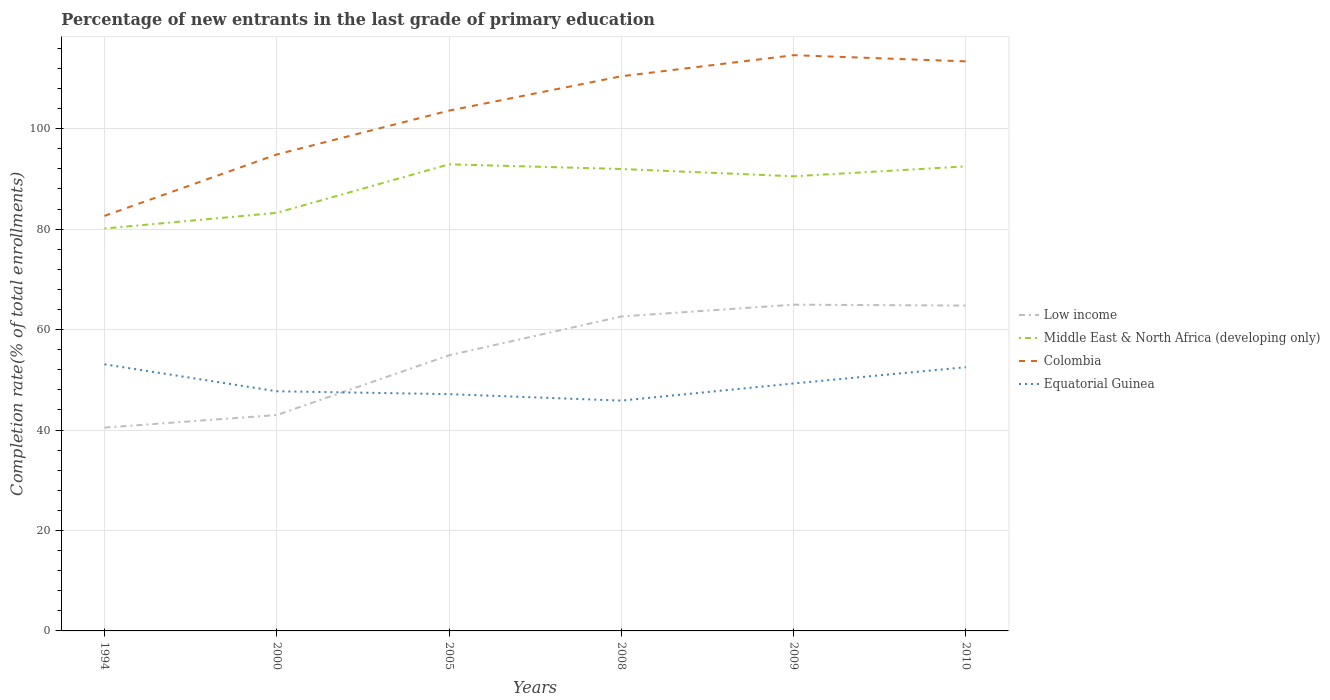Does the line corresponding to Middle East & North Africa (developing only) intersect with the line corresponding to Equatorial Guinea?
Your answer should be compact. No. Across all years, what is the maximum percentage of new entrants in Middle East & North Africa (developing only)?
Make the answer very short. 80.12. In which year was the percentage of new entrants in Equatorial Guinea maximum?
Your answer should be compact. 2008. What is the total percentage of new entrants in Equatorial Guinea in the graph?
Make the answer very short. 5.94. What is the difference between the highest and the second highest percentage of new entrants in Colombia?
Give a very brief answer. 32. What is the difference between the highest and the lowest percentage of new entrants in Equatorial Guinea?
Provide a succinct answer. 3. Is the percentage of new entrants in Middle East & North Africa (developing only) strictly greater than the percentage of new entrants in Equatorial Guinea over the years?
Provide a short and direct response. No. How many years are there in the graph?
Your answer should be compact. 6. What is the difference between two consecutive major ticks on the Y-axis?
Your response must be concise. 20. Where does the legend appear in the graph?
Your response must be concise. Center right. How many legend labels are there?
Give a very brief answer. 4. How are the legend labels stacked?
Your answer should be compact. Vertical. What is the title of the graph?
Offer a very short reply. Percentage of new entrants in the last grade of primary education. What is the label or title of the Y-axis?
Make the answer very short. Completion rate(% of total enrollments). What is the Completion rate(% of total enrollments) of Low income in 1994?
Make the answer very short. 40.48. What is the Completion rate(% of total enrollments) in Middle East & North Africa (developing only) in 1994?
Offer a terse response. 80.12. What is the Completion rate(% of total enrollments) in Colombia in 1994?
Offer a very short reply. 82.63. What is the Completion rate(% of total enrollments) in Equatorial Guinea in 1994?
Make the answer very short. 53.08. What is the Completion rate(% of total enrollments) in Low income in 2000?
Provide a succinct answer. 42.98. What is the Completion rate(% of total enrollments) in Middle East & North Africa (developing only) in 2000?
Provide a short and direct response. 83.23. What is the Completion rate(% of total enrollments) in Colombia in 2000?
Provide a succinct answer. 94.86. What is the Completion rate(% of total enrollments) of Equatorial Guinea in 2000?
Keep it short and to the point. 47.72. What is the Completion rate(% of total enrollments) of Low income in 2005?
Keep it short and to the point. 54.87. What is the Completion rate(% of total enrollments) of Middle East & North Africa (developing only) in 2005?
Provide a short and direct response. 92.9. What is the Completion rate(% of total enrollments) in Colombia in 2005?
Provide a short and direct response. 103.59. What is the Completion rate(% of total enrollments) of Equatorial Guinea in 2005?
Your answer should be very brief. 47.14. What is the Completion rate(% of total enrollments) in Low income in 2008?
Your answer should be very brief. 62.61. What is the Completion rate(% of total enrollments) of Middle East & North Africa (developing only) in 2008?
Give a very brief answer. 91.97. What is the Completion rate(% of total enrollments) in Colombia in 2008?
Your response must be concise. 110.43. What is the Completion rate(% of total enrollments) of Equatorial Guinea in 2008?
Offer a terse response. 45.85. What is the Completion rate(% of total enrollments) of Low income in 2009?
Make the answer very short. 64.95. What is the Completion rate(% of total enrollments) in Middle East & North Africa (developing only) in 2009?
Provide a short and direct response. 90.51. What is the Completion rate(% of total enrollments) in Colombia in 2009?
Offer a terse response. 114.62. What is the Completion rate(% of total enrollments) of Equatorial Guinea in 2009?
Keep it short and to the point. 49.27. What is the Completion rate(% of total enrollments) in Low income in 2010?
Make the answer very short. 64.77. What is the Completion rate(% of total enrollments) in Middle East & North Africa (developing only) in 2010?
Offer a terse response. 92.48. What is the Completion rate(% of total enrollments) in Colombia in 2010?
Offer a very short reply. 113.39. What is the Completion rate(% of total enrollments) of Equatorial Guinea in 2010?
Ensure brevity in your answer.  52.5. Across all years, what is the maximum Completion rate(% of total enrollments) in Low income?
Ensure brevity in your answer.  64.95. Across all years, what is the maximum Completion rate(% of total enrollments) in Middle East & North Africa (developing only)?
Offer a terse response. 92.9. Across all years, what is the maximum Completion rate(% of total enrollments) of Colombia?
Ensure brevity in your answer.  114.62. Across all years, what is the maximum Completion rate(% of total enrollments) of Equatorial Guinea?
Provide a succinct answer. 53.08. Across all years, what is the minimum Completion rate(% of total enrollments) of Low income?
Provide a short and direct response. 40.48. Across all years, what is the minimum Completion rate(% of total enrollments) in Middle East & North Africa (developing only)?
Your answer should be compact. 80.12. Across all years, what is the minimum Completion rate(% of total enrollments) of Colombia?
Offer a terse response. 82.63. Across all years, what is the minimum Completion rate(% of total enrollments) in Equatorial Guinea?
Your answer should be very brief. 45.85. What is the total Completion rate(% of total enrollments) in Low income in the graph?
Provide a short and direct response. 330.67. What is the total Completion rate(% of total enrollments) of Middle East & North Africa (developing only) in the graph?
Ensure brevity in your answer.  531.21. What is the total Completion rate(% of total enrollments) in Colombia in the graph?
Ensure brevity in your answer.  619.52. What is the total Completion rate(% of total enrollments) of Equatorial Guinea in the graph?
Provide a succinct answer. 295.56. What is the difference between the Completion rate(% of total enrollments) of Low income in 1994 and that in 2000?
Ensure brevity in your answer.  -2.5. What is the difference between the Completion rate(% of total enrollments) of Middle East & North Africa (developing only) in 1994 and that in 2000?
Make the answer very short. -3.12. What is the difference between the Completion rate(% of total enrollments) in Colombia in 1994 and that in 2000?
Your answer should be very brief. -12.23. What is the difference between the Completion rate(% of total enrollments) in Equatorial Guinea in 1994 and that in 2000?
Offer a terse response. 5.36. What is the difference between the Completion rate(% of total enrollments) of Low income in 1994 and that in 2005?
Your response must be concise. -14.39. What is the difference between the Completion rate(% of total enrollments) of Middle East & North Africa (developing only) in 1994 and that in 2005?
Provide a short and direct response. -12.78. What is the difference between the Completion rate(% of total enrollments) of Colombia in 1994 and that in 2005?
Offer a terse response. -20.96. What is the difference between the Completion rate(% of total enrollments) of Equatorial Guinea in 1994 and that in 2005?
Ensure brevity in your answer.  5.94. What is the difference between the Completion rate(% of total enrollments) of Low income in 1994 and that in 2008?
Provide a short and direct response. -22.12. What is the difference between the Completion rate(% of total enrollments) in Middle East & North Africa (developing only) in 1994 and that in 2008?
Give a very brief answer. -11.85. What is the difference between the Completion rate(% of total enrollments) of Colombia in 1994 and that in 2008?
Your response must be concise. -27.8. What is the difference between the Completion rate(% of total enrollments) in Equatorial Guinea in 1994 and that in 2008?
Keep it short and to the point. 7.23. What is the difference between the Completion rate(% of total enrollments) of Low income in 1994 and that in 2009?
Your answer should be compact. -24.47. What is the difference between the Completion rate(% of total enrollments) in Middle East & North Africa (developing only) in 1994 and that in 2009?
Offer a very short reply. -10.4. What is the difference between the Completion rate(% of total enrollments) of Colombia in 1994 and that in 2009?
Offer a terse response. -32. What is the difference between the Completion rate(% of total enrollments) of Equatorial Guinea in 1994 and that in 2009?
Ensure brevity in your answer.  3.81. What is the difference between the Completion rate(% of total enrollments) of Low income in 1994 and that in 2010?
Make the answer very short. -24.29. What is the difference between the Completion rate(% of total enrollments) in Middle East & North Africa (developing only) in 1994 and that in 2010?
Your answer should be very brief. -12.37. What is the difference between the Completion rate(% of total enrollments) in Colombia in 1994 and that in 2010?
Ensure brevity in your answer.  -30.77. What is the difference between the Completion rate(% of total enrollments) in Equatorial Guinea in 1994 and that in 2010?
Your answer should be very brief. 0.57. What is the difference between the Completion rate(% of total enrollments) of Low income in 2000 and that in 2005?
Offer a very short reply. -11.89. What is the difference between the Completion rate(% of total enrollments) in Middle East & North Africa (developing only) in 2000 and that in 2005?
Give a very brief answer. -9.66. What is the difference between the Completion rate(% of total enrollments) of Colombia in 2000 and that in 2005?
Your answer should be compact. -8.73. What is the difference between the Completion rate(% of total enrollments) in Equatorial Guinea in 2000 and that in 2005?
Your answer should be compact. 0.58. What is the difference between the Completion rate(% of total enrollments) in Low income in 2000 and that in 2008?
Your response must be concise. -19.62. What is the difference between the Completion rate(% of total enrollments) of Middle East & North Africa (developing only) in 2000 and that in 2008?
Your answer should be compact. -8.73. What is the difference between the Completion rate(% of total enrollments) in Colombia in 2000 and that in 2008?
Offer a terse response. -15.57. What is the difference between the Completion rate(% of total enrollments) of Equatorial Guinea in 2000 and that in 2008?
Your answer should be very brief. 1.86. What is the difference between the Completion rate(% of total enrollments) in Low income in 2000 and that in 2009?
Provide a short and direct response. -21.97. What is the difference between the Completion rate(% of total enrollments) in Middle East & North Africa (developing only) in 2000 and that in 2009?
Ensure brevity in your answer.  -7.28. What is the difference between the Completion rate(% of total enrollments) of Colombia in 2000 and that in 2009?
Make the answer very short. -19.77. What is the difference between the Completion rate(% of total enrollments) of Equatorial Guinea in 2000 and that in 2009?
Your response must be concise. -1.56. What is the difference between the Completion rate(% of total enrollments) in Low income in 2000 and that in 2010?
Your answer should be compact. -21.79. What is the difference between the Completion rate(% of total enrollments) in Middle East & North Africa (developing only) in 2000 and that in 2010?
Provide a succinct answer. -9.25. What is the difference between the Completion rate(% of total enrollments) of Colombia in 2000 and that in 2010?
Offer a very short reply. -18.54. What is the difference between the Completion rate(% of total enrollments) in Equatorial Guinea in 2000 and that in 2010?
Provide a succinct answer. -4.79. What is the difference between the Completion rate(% of total enrollments) in Low income in 2005 and that in 2008?
Provide a short and direct response. -7.73. What is the difference between the Completion rate(% of total enrollments) of Middle East & North Africa (developing only) in 2005 and that in 2008?
Make the answer very short. 0.93. What is the difference between the Completion rate(% of total enrollments) of Colombia in 2005 and that in 2008?
Offer a terse response. -6.84. What is the difference between the Completion rate(% of total enrollments) in Equatorial Guinea in 2005 and that in 2008?
Offer a very short reply. 1.29. What is the difference between the Completion rate(% of total enrollments) in Low income in 2005 and that in 2009?
Give a very brief answer. -10.08. What is the difference between the Completion rate(% of total enrollments) of Middle East & North Africa (developing only) in 2005 and that in 2009?
Provide a succinct answer. 2.38. What is the difference between the Completion rate(% of total enrollments) of Colombia in 2005 and that in 2009?
Provide a short and direct response. -11.03. What is the difference between the Completion rate(% of total enrollments) in Equatorial Guinea in 2005 and that in 2009?
Your answer should be very brief. -2.13. What is the difference between the Completion rate(% of total enrollments) in Low income in 2005 and that in 2010?
Make the answer very short. -9.9. What is the difference between the Completion rate(% of total enrollments) in Middle East & North Africa (developing only) in 2005 and that in 2010?
Give a very brief answer. 0.41. What is the difference between the Completion rate(% of total enrollments) in Colombia in 2005 and that in 2010?
Offer a very short reply. -9.81. What is the difference between the Completion rate(% of total enrollments) of Equatorial Guinea in 2005 and that in 2010?
Ensure brevity in your answer.  -5.36. What is the difference between the Completion rate(% of total enrollments) in Low income in 2008 and that in 2009?
Keep it short and to the point. -2.35. What is the difference between the Completion rate(% of total enrollments) of Middle East & North Africa (developing only) in 2008 and that in 2009?
Your answer should be very brief. 1.45. What is the difference between the Completion rate(% of total enrollments) in Colombia in 2008 and that in 2009?
Provide a short and direct response. -4.19. What is the difference between the Completion rate(% of total enrollments) in Equatorial Guinea in 2008 and that in 2009?
Your response must be concise. -3.42. What is the difference between the Completion rate(% of total enrollments) of Low income in 2008 and that in 2010?
Offer a very short reply. -2.17. What is the difference between the Completion rate(% of total enrollments) of Middle East & North Africa (developing only) in 2008 and that in 2010?
Ensure brevity in your answer.  -0.52. What is the difference between the Completion rate(% of total enrollments) of Colombia in 2008 and that in 2010?
Offer a terse response. -2.97. What is the difference between the Completion rate(% of total enrollments) in Equatorial Guinea in 2008 and that in 2010?
Offer a very short reply. -6.65. What is the difference between the Completion rate(% of total enrollments) of Low income in 2009 and that in 2010?
Your answer should be very brief. 0.18. What is the difference between the Completion rate(% of total enrollments) in Middle East & North Africa (developing only) in 2009 and that in 2010?
Your response must be concise. -1.97. What is the difference between the Completion rate(% of total enrollments) in Colombia in 2009 and that in 2010?
Your response must be concise. 1.23. What is the difference between the Completion rate(% of total enrollments) in Equatorial Guinea in 2009 and that in 2010?
Keep it short and to the point. -3.23. What is the difference between the Completion rate(% of total enrollments) of Low income in 1994 and the Completion rate(% of total enrollments) of Middle East & North Africa (developing only) in 2000?
Give a very brief answer. -42.75. What is the difference between the Completion rate(% of total enrollments) of Low income in 1994 and the Completion rate(% of total enrollments) of Colombia in 2000?
Make the answer very short. -54.38. What is the difference between the Completion rate(% of total enrollments) of Low income in 1994 and the Completion rate(% of total enrollments) of Equatorial Guinea in 2000?
Give a very brief answer. -7.24. What is the difference between the Completion rate(% of total enrollments) of Middle East & North Africa (developing only) in 1994 and the Completion rate(% of total enrollments) of Colombia in 2000?
Make the answer very short. -14.74. What is the difference between the Completion rate(% of total enrollments) of Middle East & North Africa (developing only) in 1994 and the Completion rate(% of total enrollments) of Equatorial Guinea in 2000?
Your answer should be very brief. 32.4. What is the difference between the Completion rate(% of total enrollments) of Colombia in 1994 and the Completion rate(% of total enrollments) of Equatorial Guinea in 2000?
Your answer should be very brief. 34.91. What is the difference between the Completion rate(% of total enrollments) in Low income in 1994 and the Completion rate(% of total enrollments) in Middle East & North Africa (developing only) in 2005?
Provide a short and direct response. -52.42. What is the difference between the Completion rate(% of total enrollments) in Low income in 1994 and the Completion rate(% of total enrollments) in Colombia in 2005?
Provide a short and direct response. -63.11. What is the difference between the Completion rate(% of total enrollments) in Low income in 1994 and the Completion rate(% of total enrollments) in Equatorial Guinea in 2005?
Your answer should be very brief. -6.66. What is the difference between the Completion rate(% of total enrollments) in Middle East & North Africa (developing only) in 1994 and the Completion rate(% of total enrollments) in Colombia in 2005?
Offer a terse response. -23.47. What is the difference between the Completion rate(% of total enrollments) in Middle East & North Africa (developing only) in 1994 and the Completion rate(% of total enrollments) in Equatorial Guinea in 2005?
Offer a very short reply. 32.98. What is the difference between the Completion rate(% of total enrollments) of Colombia in 1994 and the Completion rate(% of total enrollments) of Equatorial Guinea in 2005?
Make the answer very short. 35.49. What is the difference between the Completion rate(% of total enrollments) in Low income in 1994 and the Completion rate(% of total enrollments) in Middle East & North Africa (developing only) in 2008?
Offer a terse response. -51.49. What is the difference between the Completion rate(% of total enrollments) in Low income in 1994 and the Completion rate(% of total enrollments) in Colombia in 2008?
Keep it short and to the point. -69.95. What is the difference between the Completion rate(% of total enrollments) of Low income in 1994 and the Completion rate(% of total enrollments) of Equatorial Guinea in 2008?
Offer a terse response. -5.37. What is the difference between the Completion rate(% of total enrollments) of Middle East & North Africa (developing only) in 1994 and the Completion rate(% of total enrollments) of Colombia in 2008?
Your response must be concise. -30.31. What is the difference between the Completion rate(% of total enrollments) in Middle East & North Africa (developing only) in 1994 and the Completion rate(% of total enrollments) in Equatorial Guinea in 2008?
Keep it short and to the point. 34.26. What is the difference between the Completion rate(% of total enrollments) in Colombia in 1994 and the Completion rate(% of total enrollments) in Equatorial Guinea in 2008?
Your answer should be compact. 36.78. What is the difference between the Completion rate(% of total enrollments) in Low income in 1994 and the Completion rate(% of total enrollments) in Middle East & North Africa (developing only) in 2009?
Provide a short and direct response. -50.03. What is the difference between the Completion rate(% of total enrollments) of Low income in 1994 and the Completion rate(% of total enrollments) of Colombia in 2009?
Offer a terse response. -74.14. What is the difference between the Completion rate(% of total enrollments) of Low income in 1994 and the Completion rate(% of total enrollments) of Equatorial Guinea in 2009?
Offer a very short reply. -8.79. What is the difference between the Completion rate(% of total enrollments) of Middle East & North Africa (developing only) in 1994 and the Completion rate(% of total enrollments) of Colombia in 2009?
Offer a terse response. -34.51. What is the difference between the Completion rate(% of total enrollments) in Middle East & North Africa (developing only) in 1994 and the Completion rate(% of total enrollments) in Equatorial Guinea in 2009?
Keep it short and to the point. 30.84. What is the difference between the Completion rate(% of total enrollments) of Colombia in 1994 and the Completion rate(% of total enrollments) of Equatorial Guinea in 2009?
Your answer should be very brief. 33.36. What is the difference between the Completion rate(% of total enrollments) in Low income in 1994 and the Completion rate(% of total enrollments) in Middle East & North Africa (developing only) in 2010?
Offer a very short reply. -52. What is the difference between the Completion rate(% of total enrollments) in Low income in 1994 and the Completion rate(% of total enrollments) in Colombia in 2010?
Give a very brief answer. -72.91. What is the difference between the Completion rate(% of total enrollments) in Low income in 1994 and the Completion rate(% of total enrollments) in Equatorial Guinea in 2010?
Provide a short and direct response. -12.02. What is the difference between the Completion rate(% of total enrollments) of Middle East & North Africa (developing only) in 1994 and the Completion rate(% of total enrollments) of Colombia in 2010?
Your answer should be compact. -33.28. What is the difference between the Completion rate(% of total enrollments) of Middle East & North Africa (developing only) in 1994 and the Completion rate(% of total enrollments) of Equatorial Guinea in 2010?
Offer a terse response. 27.61. What is the difference between the Completion rate(% of total enrollments) in Colombia in 1994 and the Completion rate(% of total enrollments) in Equatorial Guinea in 2010?
Offer a very short reply. 30.12. What is the difference between the Completion rate(% of total enrollments) in Low income in 2000 and the Completion rate(% of total enrollments) in Middle East & North Africa (developing only) in 2005?
Ensure brevity in your answer.  -49.92. What is the difference between the Completion rate(% of total enrollments) of Low income in 2000 and the Completion rate(% of total enrollments) of Colombia in 2005?
Provide a succinct answer. -60.61. What is the difference between the Completion rate(% of total enrollments) of Low income in 2000 and the Completion rate(% of total enrollments) of Equatorial Guinea in 2005?
Ensure brevity in your answer.  -4.16. What is the difference between the Completion rate(% of total enrollments) in Middle East & North Africa (developing only) in 2000 and the Completion rate(% of total enrollments) in Colombia in 2005?
Provide a succinct answer. -20.35. What is the difference between the Completion rate(% of total enrollments) in Middle East & North Africa (developing only) in 2000 and the Completion rate(% of total enrollments) in Equatorial Guinea in 2005?
Provide a succinct answer. 36.09. What is the difference between the Completion rate(% of total enrollments) of Colombia in 2000 and the Completion rate(% of total enrollments) of Equatorial Guinea in 2005?
Give a very brief answer. 47.72. What is the difference between the Completion rate(% of total enrollments) in Low income in 2000 and the Completion rate(% of total enrollments) in Middle East & North Africa (developing only) in 2008?
Make the answer very short. -48.99. What is the difference between the Completion rate(% of total enrollments) of Low income in 2000 and the Completion rate(% of total enrollments) of Colombia in 2008?
Give a very brief answer. -67.45. What is the difference between the Completion rate(% of total enrollments) of Low income in 2000 and the Completion rate(% of total enrollments) of Equatorial Guinea in 2008?
Your response must be concise. -2.87. What is the difference between the Completion rate(% of total enrollments) in Middle East & North Africa (developing only) in 2000 and the Completion rate(% of total enrollments) in Colombia in 2008?
Offer a very short reply. -27.19. What is the difference between the Completion rate(% of total enrollments) of Middle East & North Africa (developing only) in 2000 and the Completion rate(% of total enrollments) of Equatorial Guinea in 2008?
Give a very brief answer. 37.38. What is the difference between the Completion rate(% of total enrollments) of Colombia in 2000 and the Completion rate(% of total enrollments) of Equatorial Guinea in 2008?
Offer a very short reply. 49.01. What is the difference between the Completion rate(% of total enrollments) in Low income in 2000 and the Completion rate(% of total enrollments) in Middle East & North Africa (developing only) in 2009?
Your answer should be very brief. -47.53. What is the difference between the Completion rate(% of total enrollments) of Low income in 2000 and the Completion rate(% of total enrollments) of Colombia in 2009?
Your answer should be very brief. -71.64. What is the difference between the Completion rate(% of total enrollments) in Low income in 2000 and the Completion rate(% of total enrollments) in Equatorial Guinea in 2009?
Give a very brief answer. -6.29. What is the difference between the Completion rate(% of total enrollments) in Middle East & North Africa (developing only) in 2000 and the Completion rate(% of total enrollments) in Colombia in 2009?
Keep it short and to the point. -31.39. What is the difference between the Completion rate(% of total enrollments) of Middle East & North Africa (developing only) in 2000 and the Completion rate(% of total enrollments) of Equatorial Guinea in 2009?
Your response must be concise. 33.96. What is the difference between the Completion rate(% of total enrollments) of Colombia in 2000 and the Completion rate(% of total enrollments) of Equatorial Guinea in 2009?
Your answer should be very brief. 45.59. What is the difference between the Completion rate(% of total enrollments) in Low income in 2000 and the Completion rate(% of total enrollments) in Middle East & North Africa (developing only) in 2010?
Give a very brief answer. -49.5. What is the difference between the Completion rate(% of total enrollments) in Low income in 2000 and the Completion rate(% of total enrollments) in Colombia in 2010?
Ensure brevity in your answer.  -70.41. What is the difference between the Completion rate(% of total enrollments) of Low income in 2000 and the Completion rate(% of total enrollments) of Equatorial Guinea in 2010?
Your response must be concise. -9.52. What is the difference between the Completion rate(% of total enrollments) in Middle East & North Africa (developing only) in 2000 and the Completion rate(% of total enrollments) in Colombia in 2010?
Your answer should be compact. -30.16. What is the difference between the Completion rate(% of total enrollments) in Middle East & North Africa (developing only) in 2000 and the Completion rate(% of total enrollments) in Equatorial Guinea in 2010?
Offer a very short reply. 30.73. What is the difference between the Completion rate(% of total enrollments) of Colombia in 2000 and the Completion rate(% of total enrollments) of Equatorial Guinea in 2010?
Your answer should be very brief. 42.35. What is the difference between the Completion rate(% of total enrollments) of Low income in 2005 and the Completion rate(% of total enrollments) of Middle East & North Africa (developing only) in 2008?
Your response must be concise. -37.1. What is the difference between the Completion rate(% of total enrollments) in Low income in 2005 and the Completion rate(% of total enrollments) in Colombia in 2008?
Your response must be concise. -55.56. What is the difference between the Completion rate(% of total enrollments) in Low income in 2005 and the Completion rate(% of total enrollments) in Equatorial Guinea in 2008?
Offer a terse response. 9.02. What is the difference between the Completion rate(% of total enrollments) of Middle East & North Africa (developing only) in 2005 and the Completion rate(% of total enrollments) of Colombia in 2008?
Offer a very short reply. -17.53. What is the difference between the Completion rate(% of total enrollments) in Middle East & North Africa (developing only) in 2005 and the Completion rate(% of total enrollments) in Equatorial Guinea in 2008?
Ensure brevity in your answer.  47.05. What is the difference between the Completion rate(% of total enrollments) of Colombia in 2005 and the Completion rate(% of total enrollments) of Equatorial Guinea in 2008?
Provide a succinct answer. 57.74. What is the difference between the Completion rate(% of total enrollments) in Low income in 2005 and the Completion rate(% of total enrollments) in Middle East & North Africa (developing only) in 2009?
Offer a terse response. -35.64. What is the difference between the Completion rate(% of total enrollments) of Low income in 2005 and the Completion rate(% of total enrollments) of Colombia in 2009?
Your answer should be compact. -59.75. What is the difference between the Completion rate(% of total enrollments) in Low income in 2005 and the Completion rate(% of total enrollments) in Equatorial Guinea in 2009?
Provide a succinct answer. 5.6. What is the difference between the Completion rate(% of total enrollments) of Middle East & North Africa (developing only) in 2005 and the Completion rate(% of total enrollments) of Colombia in 2009?
Keep it short and to the point. -21.73. What is the difference between the Completion rate(% of total enrollments) in Middle East & North Africa (developing only) in 2005 and the Completion rate(% of total enrollments) in Equatorial Guinea in 2009?
Offer a very short reply. 43.62. What is the difference between the Completion rate(% of total enrollments) in Colombia in 2005 and the Completion rate(% of total enrollments) in Equatorial Guinea in 2009?
Provide a short and direct response. 54.32. What is the difference between the Completion rate(% of total enrollments) in Low income in 2005 and the Completion rate(% of total enrollments) in Middle East & North Africa (developing only) in 2010?
Ensure brevity in your answer.  -37.61. What is the difference between the Completion rate(% of total enrollments) in Low income in 2005 and the Completion rate(% of total enrollments) in Colombia in 2010?
Give a very brief answer. -58.52. What is the difference between the Completion rate(% of total enrollments) of Low income in 2005 and the Completion rate(% of total enrollments) of Equatorial Guinea in 2010?
Give a very brief answer. 2.37. What is the difference between the Completion rate(% of total enrollments) of Middle East & North Africa (developing only) in 2005 and the Completion rate(% of total enrollments) of Colombia in 2010?
Your answer should be compact. -20.5. What is the difference between the Completion rate(% of total enrollments) of Middle East & North Africa (developing only) in 2005 and the Completion rate(% of total enrollments) of Equatorial Guinea in 2010?
Your answer should be compact. 40.39. What is the difference between the Completion rate(% of total enrollments) in Colombia in 2005 and the Completion rate(% of total enrollments) in Equatorial Guinea in 2010?
Your answer should be very brief. 51.08. What is the difference between the Completion rate(% of total enrollments) of Low income in 2008 and the Completion rate(% of total enrollments) of Middle East & North Africa (developing only) in 2009?
Offer a terse response. -27.91. What is the difference between the Completion rate(% of total enrollments) in Low income in 2008 and the Completion rate(% of total enrollments) in Colombia in 2009?
Keep it short and to the point. -52.02. What is the difference between the Completion rate(% of total enrollments) of Low income in 2008 and the Completion rate(% of total enrollments) of Equatorial Guinea in 2009?
Offer a very short reply. 13.33. What is the difference between the Completion rate(% of total enrollments) of Middle East & North Africa (developing only) in 2008 and the Completion rate(% of total enrollments) of Colombia in 2009?
Your answer should be compact. -22.66. What is the difference between the Completion rate(% of total enrollments) of Middle East & North Africa (developing only) in 2008 and the Completion rate(% of total enrollments) of Equatorial Guinea in 2009?
Offer a very short reply. 42.7. What is the difference between the Completion rate(% of total enrollments) in Colombia in 2008 and the Completion rate(% of total enrollments) in Equatorial Guinea in 2009?
Offer a terse response. 61.16. What is the difference between the Completion rate(% of total enrollments) in Low income in 2008 and the Completion rate(% of total enrollments) in Middle East & North Africa (developing only) in 2010?
Keep it short and to the point. -29.88. What is the difference between the Completion rate(% of total enrollments) of Low income in 2008 and the Completion rate(% of total enrollments) of Colombia in 2010?
Make the answer very short. -50.79. What is the difference between the Completion rate(% of total enrollments) of Low income in 2008 and the Completion rate(% of total enrollments) of Equatorial Guinea in 2010?
Your response must be concise. 10.1. What is the difference between the Completion rate(% of total enrollments) in Middle East & North Africa (developing only) in 2008 and the Completion rate(% of total enrollments) in Colombia in 2010?
Offer a very short reply. -21.43. What is the difference between the Completion rate(% of total enrollments) in Middle East & North Africa (developing only) in 2008 and the Completion rate(% of total enrollments) in Equatorial Guinea in 2010?
Your response must be concise. 39.46. What is the difference between the Completion rate(% of total enrollments) in Colombia in 2008 and the Completion rate(% of total enrollments) in Equatorial Guinea in 2010?
Your answer should be compact. 57.92. What is the difference between the Completion rate(% of total enrollments) in Low income in 2009 and the Completion rate(% of total enrollments) in Middle East & North Africa (developing only) in 2010?
Your response must be concise. -27.53. What is the difference between the Completion rate(% of total enrollments) in Low income in 2009 and the Completion rate(% of total enrollments) in Colombia in 2010?
Ensure brevity in your answer.  -48.44. What is the difference between the Completion rate(% of total enrollments) of Low income in 2009 and the Completion rate(% of total enrollments) of Equatorial Guinea in 2010?
Keep it short and to the point. 12.45. What is the difference between the Completion rate(% of total enrollments) of Middle East & North Africa (developing only) in 2009 and the Completion rate(% of total enrollments) of Colombia in 2010?
Offer a very short reply. -22.88. What is the difference between the Completion rate(% of total enrollments) in Middle East & North Africa (developing only) in 2009 and the Completion rate(% of total enrollments) in Equatorial Guinea in 2010?
Ensure brevity in your answer.  38.01. What is the difference between the Completion rate(% of total enrollments) in Colombia in 2009 and the Completion rate(% of total enrollments) in Equatorial Guinea in 2010?
Provide a succinct answer. 62.12. What is the average Completion rate(% of total enrollments) in Low income per year?
Give a very brief answer. 55.11. What is the average Completion rate(% of total enrollments) of Middle East & North Africa (developing only) per year?
Offer a terse response. 88.54. What is the average Completion rate(% of total enrollments) in Colombia per year?
Your response must be concise. 103.25. What is the average Completion rate(% of total enrollments) in Equatorial Guinea per year?
Your answer should be very brief. 49.26. In the year 1994, what is the difference between the Completion rate(% of total enrollments) in Low income and Completion rate(% of total enrollments) in Middle East & North Africa (developing only)?
Ensure brevity in your answer.  -39.63. In the year 1994, what is the difference between the Completion rate(% of total enrollments) of Low income and Completion rate(% of total enrollments) of Colombia?
Offer a very short reply. -42.15. In the year 1994, what is the difference between the Completion rate(% of total enrollments) of Low income and Completion rate(% of total enrollments) of Equatorial Guinea?
Offer a very short reply. -12.6. In the year 1994, what is the difference between the Completion rate(% of total enrollments) in Middle East & North Africa (developing only) and Completion rate(% of total enrollments) in Colombia?
Keep it short and to the point. -2.51. In the year 1994, what is the difference between the Completion rate(% of total enrollments) of Middle East & North Africa (developing only) and Completion rate(% of total enrollments) of Equatorial Guinea?
Your response must be concise. 27.04. In the year 1994, what is the difference between the Completion rate(% of total enrollments) of Colombia and Completion rate(% of total enrollments) of Equatorial Guinea?
Keep it short and to the point. 29.55. In the year 2000, what is the difference between the Completion rate(% of total enrollments) of Low income and Completion rate(% of total enrollments) of Middle East & North Africa (developing only)?
Provide a succinct answer. -40.25. In the year 2000, what is the difference between the Completion rate(% of total enrollments) in Low income and Completion rate(% of total enrollments) in Colombia?
Provide a succinct answer. -51.88. In the year 2000, what is the difference between the Completion rate(% of total enrollments) of Low income and Completion rate(% of total enrollments) of Equatorial Guinea?
Offer a very short reply. -4.74. In the year 2000, what is the difference between the Completion rate(% of total enrollments) in Middle East & North Africa (developing only) and Completion rate(% of total enrollments) in Colombia?
Give a very brief answer. -11.62. In the year 2000, what is the difference between the Completion rate(% of total enrollments) of Middle East & North Africa (developing only) and Completion rate(% of total enrollments) of Equatorial Guinea?
Give a very brief answer. 35.52. In the year 2000, what is the difference between the Completion rate(% of total enrollments) in Colombia and Completion rate(% of total enrollments) in Equatorial Guinea?
Ensure brevity in your answer.  47.14. In the year 2005, what is the difference between the Completion rate(% of total enrollments) of Low income and Completion rate(% of total enrollments) of Middle East & North Africa (developing only)?
Keep it short and to the point. -38.02. In the year 2005, what is the difference between the Completion rate(% of total enrollments) of Low income and Completion rate(% of total enrollments) of Colombia?
Provide a short and direct response. -48.72. In the year 2005, what is the difference between the Completion rate(% of total enrollments) in Low income and Completion rate(% of total enrollments) in Equatorial Guinea?
Your answer should be very brief. 7.73. In the year 2005, what is the difference between the Completion rate(% of total enrollments) of Middle East & North Africa (developing only) and Completion rate(% of total enrollments) of Colombia?
Offer a terse response. -10.69. In the year 2005, what is the difference between the Completion rate(% of total enrollments) of Middle East & North Africa (developing only) and Completion rate(% of total enrollments) of Equatorial Guinea?
Offer a very short reply. 45.76. In the year 2005, what is the difference between the Completion rate(% of total enrollments) of Colombia and Completion rate(% of total enrollments) of Equatorial Guinea?
Your answer should be compact. 56.45. In the year 2008, what is the difference between the Completion rate(% of total enrollments) in Low income and Completion rate(% of total enrollments) in Middle East & North Africa (developing only)?
Offer a terse response. -29.36. In the year 2008, what is the difference between the Completion rate(% of total enrollments) of Low income and Completion rate(% of total enrollments) of Colombia?
Make the answer very short. -47.82. In the year 2008, what is the difference between the Completion rate(% of total enrollments) in Low income and Completion rate(% of total enrollments) in Equatorial Guinea?
Provide a succinct answer. 16.75. In the year 2008, what is the difference between the Completion rate(% of total enrollments) of Middle East & North Africa (developing only) and Completion rate(% of total enrollments) of Colombia?
Keep it short and to the point. -18.46. In the year 2008, what is the difference between the Completion rate(% of total enrollments) in Middle East & North Africa (developing only) and Completion rate(% of total enrollments) in Equatorial Guinea?
Ensure brevity in your answer.  46.12. In the year 2008, what is the difference between the Completion rate(% of total enrollments) in Colombia and Completion rate(% of total enrollments) in Equatorial Guinea?
Offer a terse response. 64.58. In the year 2009, what is the difference between the Completion rate(% of total enrollments) in Low income and Completion rate(% of total enrollments) in Middle East & North Africa (developing only)?
Ensure brevity in your answer.  -25.56. In the year 2009, what is the difference between the Completion rate(% of total enrollments) in Low income and Completion rate(% of total enrollments) in Colombia?
Keep it short and to the point. -49.67. In the year 2009, what is the difference between the Completion rate(% of total enrollments) of Low income and Completion rate(% of total enrollments) of Equatorial Guinea?
Your answer should be very brief. 15.68. In the year 2009, what is the difference between the Completion rate(% of total enrollments) in Middle East & North Africa (developing only) and Completion rate(% of total enrollments) in Colombia?
Keep it short and to the point. -24.11. In the year 2009, what is the difference between the Completion rate(% of total enrollments) in Middle East & North Africa (developing only) and Completion rate(% of total enrollments) in Equatorial Guinea?
Your answer should be compact. 41.24. In the year 2009, what is the difference between the Completion rate(% of total enrollments) of Colombia and Completion rate(% of total enrollments) of Equatorial Guinea?
Offer a terse response. 65.35. In the year 2010, what is the difference between the Completion rate(% of total enrollments) of Low income and Completion rate(% of total enrollments) of Middle East & North Africa (developing only)?
Provide a succinct answer. -27.71. In the year 2010, what is the difference between the Completion rate(% of total enrollments) in Low income and Completion rate(% of total enrollments) in Colombia?
Give a very brief answer. -48.62. In the year 2010, what is the difference between the Completion rate(% of total enrollments) in Low income and Completion rate(% of total enrollments) in Equatorial Guinea?
Give a very brief answer. 12.27. In the year 2010, what is the difference between the Completion rate(% of total enrollments) of Middle East & North Africa (developing only) and Completion rate(% of total enrollments) of Colombia?
Offer a very short reply. -20.91. In the year 2010, what is the difference between the Completion rate(% of total enrollments) in Middle East & North Africa (developing only) and Completion rate(% of total enrollments) in Equatorial Guinea?
Make the answer very short. 39.98. In the year 2010, what is the difference between the Completion rate(% of total enrollments) in Colombia and Completion rate(% of total enrollments) in Equatorial Guinea?
Provide a short and direct response. 60.89. What is the ratio of the Completion rate(% of total enrollments) of Low income in 1994 to that in 2000?
Provide a succinct answer. 0.94. What is the ratio of the Completion rate(% of total enrollments) of Middle East & North Africa (developing only) in 1994 to that in 2000?
Provide a succinct answer. 0.96. What is the ratio of the Completion rate(% of total enrollments) in Colombia in 1994 to that in 2000?
Provide a succinct answer. 0.87. What is the ratio of the Completion rate(% of total enrollments) in Equatorial Guinea in 1994 to that in 2000?
Offer a terse response. 1.11. What is the ratio of the Completion rate(% of total enrollments) in Low income in 1994 to that in 2005?
Your answer should be compact. 0.74. What is the ratio of the Completion rate(% of total enrollments) of Middle East & North Africa (developing only) in 1994 to that in 2005?
Ensure brevity in your answer.  0.86. What is the ratio of the Completion rate(% of total enrollments) of Colombia in 1994 to that in 2005?
Provide a short and direct response. 0.8. What is the ratio of the Completion rate(% of total enrollments) in Equatorial Guinea in 1994 to that in 2005?
Your response must be concise. 1.13. What is the ratio of the Completion rate(% of total enrollments) of Low income in 1994 to that in 2008?
Provide a succinct answer. 0.65. What is the ratio of the Completion rate(% of total enrollments) of Middle East & North Africa (developing only) in 1994 to that in 2008?
Your answer should be compact. 0.87. What is the ratio of the Completion rate(% of total enrollments) of Colombia in 1994 to that in 2008?
Your response must be concise. 0.75. What is the ratio of the Completion rate(% of total enrollments) of Equatorial Guinea in 1994 to that in 2008?
Offer a very short reply. 1.16. What is the ratio of the Completion rate(% of total enrollments) in Low income in 1994 to that in 2009?
Keep it short and to the point. 0.62. What is the ratio of the Completion rate(% of total enrollments) in Middle East & North Africa (developing only) in 1994 to that in 2009?
Give a very brief answer. 0.89. What is the ratio of the Completion rate(% of total enrollments) in Colombia in 1994 to that in 2009?
Offer a terse response. 0.72. What is the ratio of the Completion rate(% of total enrollments) of Equatorial Guinea in 1994 to that in 2009?
Make the answer very short. 1.08. What is the ratio of the Completion rate(% of total enrollments) in Low income in 1994 to that in 2010?
Your response must be concise. 0.62. What is the ratio of the Completion rate(% of total enrollments) of Middle East & North Africa (developing only) in 1994 to that in 2010?
Give a very brief answer. 0.87. What is the ratio of the Completion rate(% of total enrollments) of Colombia in 1994 to that in 2010?
Your answer should be very brief. 0.73. What is the ratio of the Completion rate(% of total enrollments) of Low income in 2000 to that in 2005?
Your answer should be very brief. 0.78. What is the ratio of the Completion rate(% of total enrollments) in Middle East & North Africa (developing only) in 2000 to that in 2005?
Your response must be concise. 0.9. What is the ratio of the Completion rate(% of total enrollments) of Colombia in 2000 to that in 2005?
Make the answer very short. 0.92. What is the ratio of the Completion rate(% of total enrollments) in Equatorial Guinea in 2000 to that in 2005?
Provide a short and direct response. 1.01. What is the ratio of the Completion rate(% of total enrollments) of Low income in 2000 to that in 2008?
Make the answer very short. 0.69. What is the ratio of the Completion rate(% of total enrollments) of Middle East & North Africa (developing only) in 2000 to that in 2008?
Ensure brevity in your answer.  0.91. What is the ratio of the Completion rate(% of total enrollments) in Colombia in 2000 to that in 2008?
Your response must be concise. 0.86. What is the ratio of the Completion rate(% of total enrollments) in Equatorial Guinea in 2000 to that in 2008?
Offer a very short reply. 1.04. What is the ratio of the Completion rate(% of total enrollments) of Low income in 2000 to that in 2009?
Your response must be concise. 0.66. What is the ratio of the Completion rate(% of total enrollments) of Middle East & North Africa (developing only) in 2000 to that in 2009?
Make the answer very short. 0.92. What is the ratio of the Completion rate(% of total enrollments) in Colombia in 2000 to that in 2009?
Offer a very short reply. 0.83. What is the ratio of the Completion rate(% of total enrollments) of Equatorial Guinea in 2000 to that in 2009?
Make the answer very short. 0.97. What is the ratio of the Completion rate(% of total enrollments) of Low income in 2000 to that in 2010?
Keep it short and to the point. 0.66. What is the ratio of the Completion rate(% of total enrollments) in Middle East & North Africa (developing only) in 2000 to that in 2010?
Make the answer very short. 0.9. What is the ratio of the Completion rate(% of total enrollments) in Colombia in 2000 to that in 2010?
Provide a short and direct response. 0.84. What is the ratio of the Completion rate(% of total enrollments) of Equatorial Guinea in 2000 to that in 2010?
Your answer should be compact. 0.91. What is the ratio of the Completion rate(% of total enrollments) of Low income in 2005 to that in 2008?
Keep it short and to the point. 0.88. What is the ratio of the Completion rate(% of total enrollments) of Colombia in 2005 to that in 2008?
Provide a succinct answer. 0.94. What is the ratio of the Completion rate(% of total enrollments) of Equatorial Guinea in 2005 to that in 2008?
Keep it short and to the point. 1.03. What is the ratio of the Completion rate(% of total enrollments) of Low income in 2005 to that in 2009?
Provide a short and direct response. 0.84. What is the ratio of the Completion rate(% of total enrollments) in Middle East & North Africa (developing only) in 2005 to that in 2009?
Your answer should be compact. 1.03. What is the ratio of the Completion rate(% of total enrollments) of Colombia in 2005 to that in 2009?
Keep it short and to the point. 0.9. What is the ratio of the Completion rate(% of total enrollments) in Equatorial Guinea in 2005 to that in 2009?
Your answer should be compact. 0.96. What is the ratio of the Completion rate(% of total enrollments) of Low income in 2005 to that in 2010?
Ensure brevity in your answer.  0.85. What is the ratio of the Completion rate(% of total enrollments) of Middle East & North Africa (developing only) in 2005 to that in 2010?
Keep it short and to the point. 1. What is the ratio of the Completion rate(% of total enrollments) in Colombia in 2005 to that in 2010?
Your answer should be compact. 0.91. What is the ratio of the Completion rate(% of total enrollments) in Equatorial Guinea in 2005 to that in 2010?
Your response must be concise. 0.9. What is the ratio of the Completion rate(% of total enrollments) in Low income in 2008 to that in 2009?
Ensure brevity in your answer.  0.96. What is the ratio of the Completion rate(% of total enrollments) in Middle East & North Africa (developing only) in 2008 to that in 2009?
Your answer should be compact. 1.02. What is the ratio of the Completion rate(% of total enrollments) of Colombia in 2008 to that in 2009?
Your response must be concise. 0.96. What is the ratio of the Completion rate(% of total enrollments) in Equatorial Guinea in 2008 to that in 2009?
Provide a short and direct response. 0.93. What is the ratio of the Completion rate(% of total enrollments) in Low income in 2008 to that in 2010?
Make the answer very short. 0.97. What is the ratio of the Completion rate(% of total enrollments) of Colombia in 2008 to that in 2010?
Your answer should be very brief. 0.97. What is the ratio of the Completion rate(% of total enrollments) of Equatorial Guinea in 2008 to that in 2010?
Keep it short and to the point. 0.87. What is the ratio of the Completion rate(% of total enrollments) of Low income in 2009 to that in 2010?
Offer a very short reply. 1. What is the ratio of the Completion rate(% of total enrollments) of Middle East & North Africa (developing only) in 2009 to that in 2010?
Make the answer very short. 0.98. What is the ratio of the Completion rate(% of total enrollments) of Colombia in 2009 to that in 2010?
Give a very brief answer. 1.01. What is the ratio of the Completion rate(% of total enrollments) of Equatorial Guinea in 2009 to that in 2010?
Ensure brevity in your answer.  0.94. What is the difference between the highest and the second highest Completion rate(% of total enrollments) in Low income?
Keep it short and to the point. 0.18. What is the difference between the highest and the second highest Completion rate(% of total enrollments) of Middle East & North Africa (developing only)?
Keep it short and to the point. 0.41. What is the difference between the highest and the second highest Completion rate(% of total enrollments) in Colombia?
Provide a short and direct response. 1.23. What is the difference between the highest and the second highest Completion rate(% of total enrollments) in Equatorial Guinea?
Keep it short and to the point. 0.57. What is the difference between the highest and the lowest Completion rate(% of total enrollments) in Low income?
Give a very brief answer. 24.47. What is the difference between the highest and the lowest Completion rate(% of total enrollments) of Middle East & North Africa (developing only)?
Your response must be concise. 12.78. What is the difference between the highest and the lowest Completion rate(% of total enrollments) in Colombia?
Provide a short and direct response. 32. What is the difference between the highest and the lowest Completion rate(% of total enrollments) of Equatorial Guinea?
Provide a succinct answer. 7.23. 